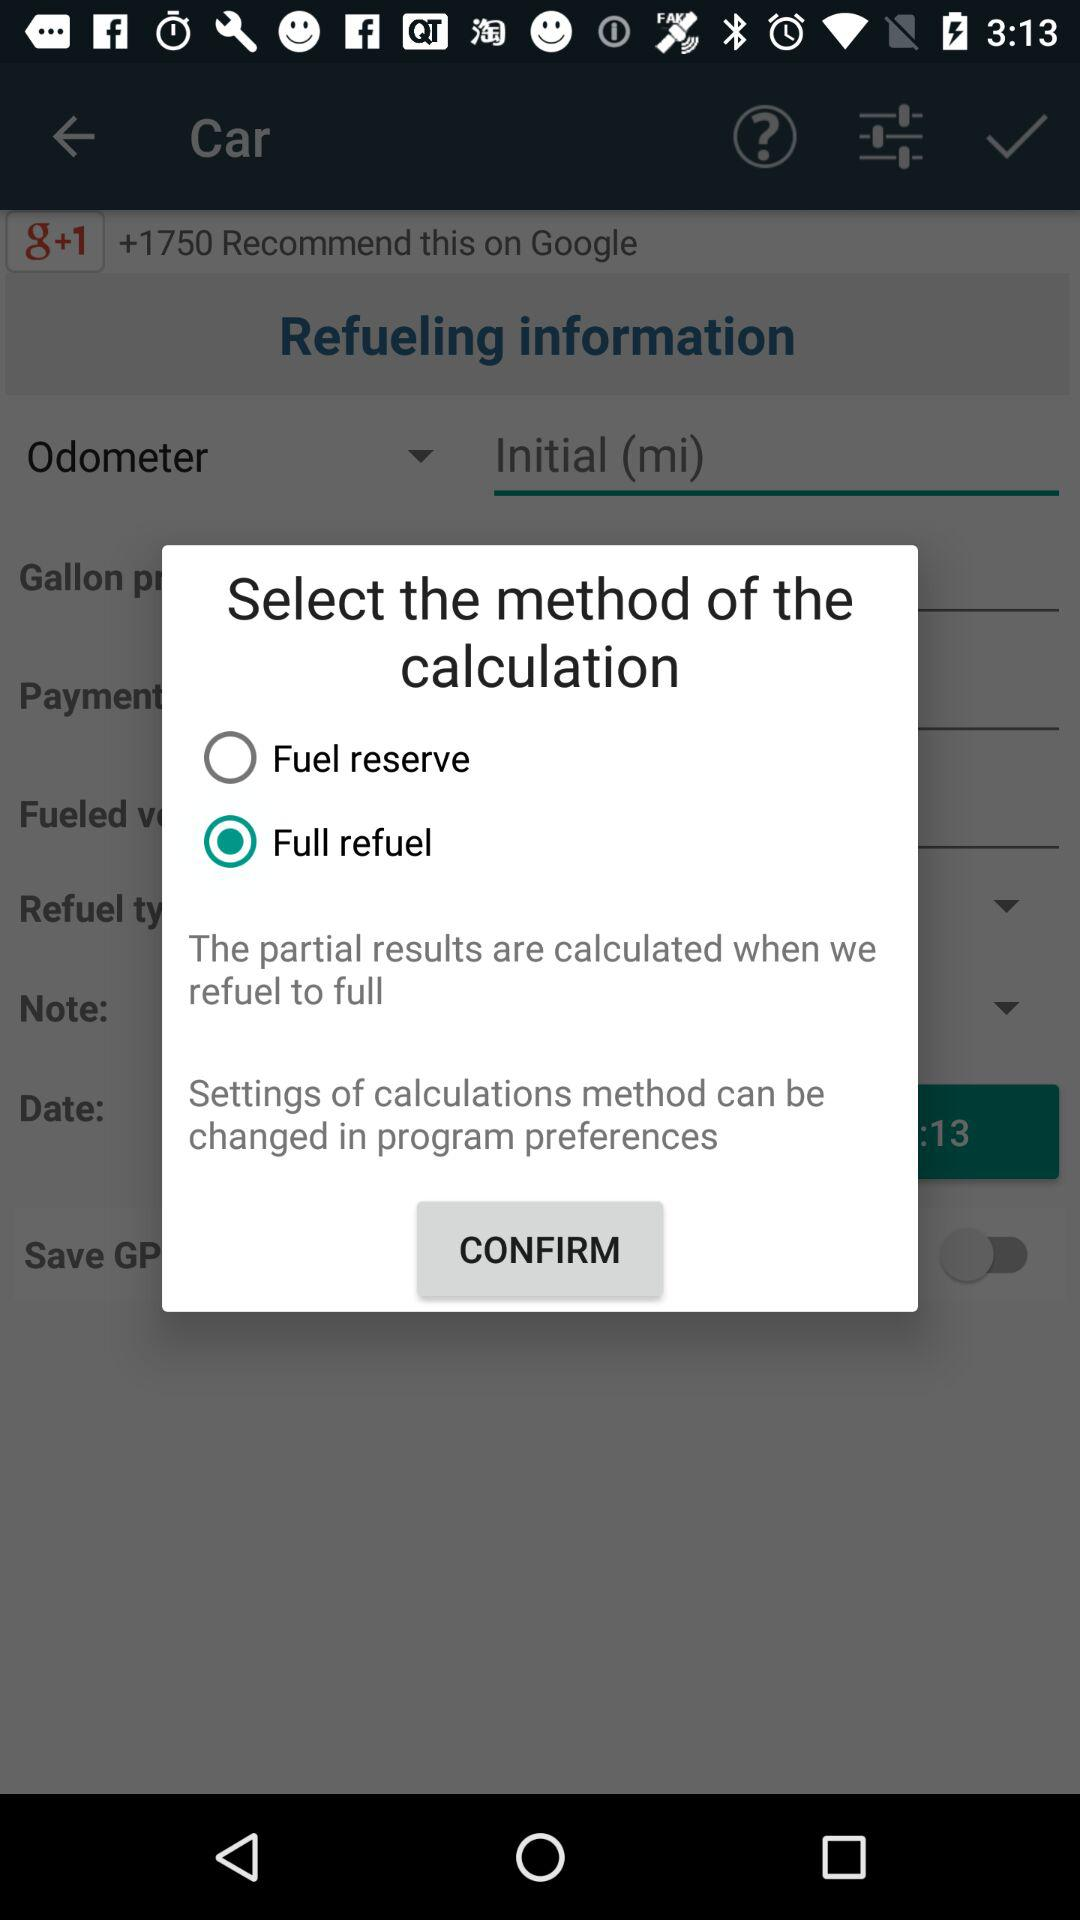What is the unit for the odometer? The unit for the odometer is "Initial (mi)". 